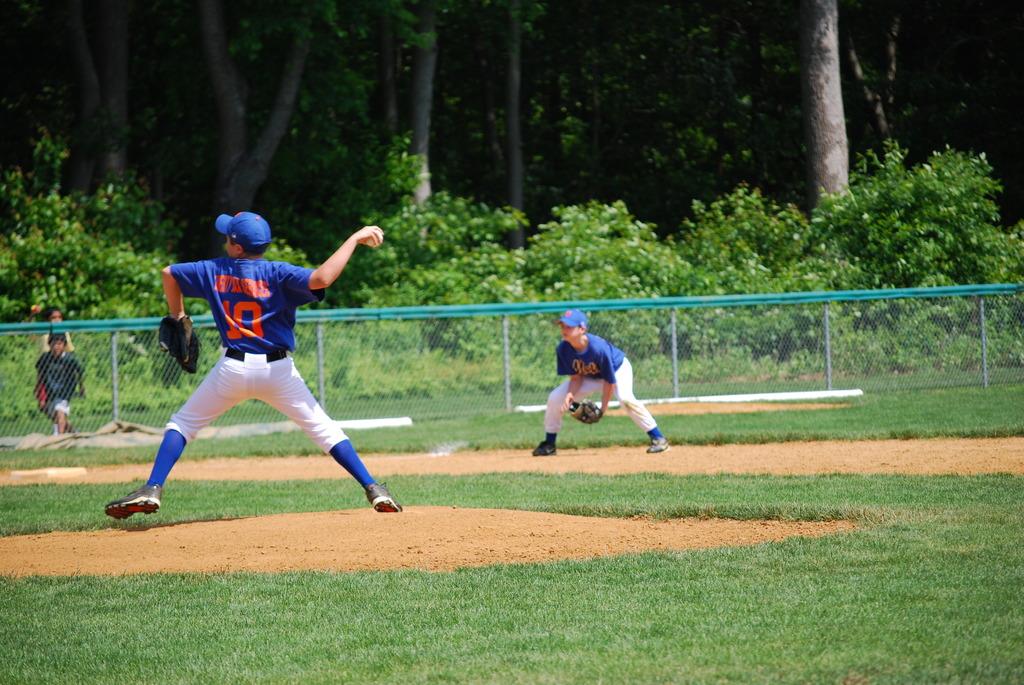What player number is the pitcher?
Keep it short and to the point. 10. 